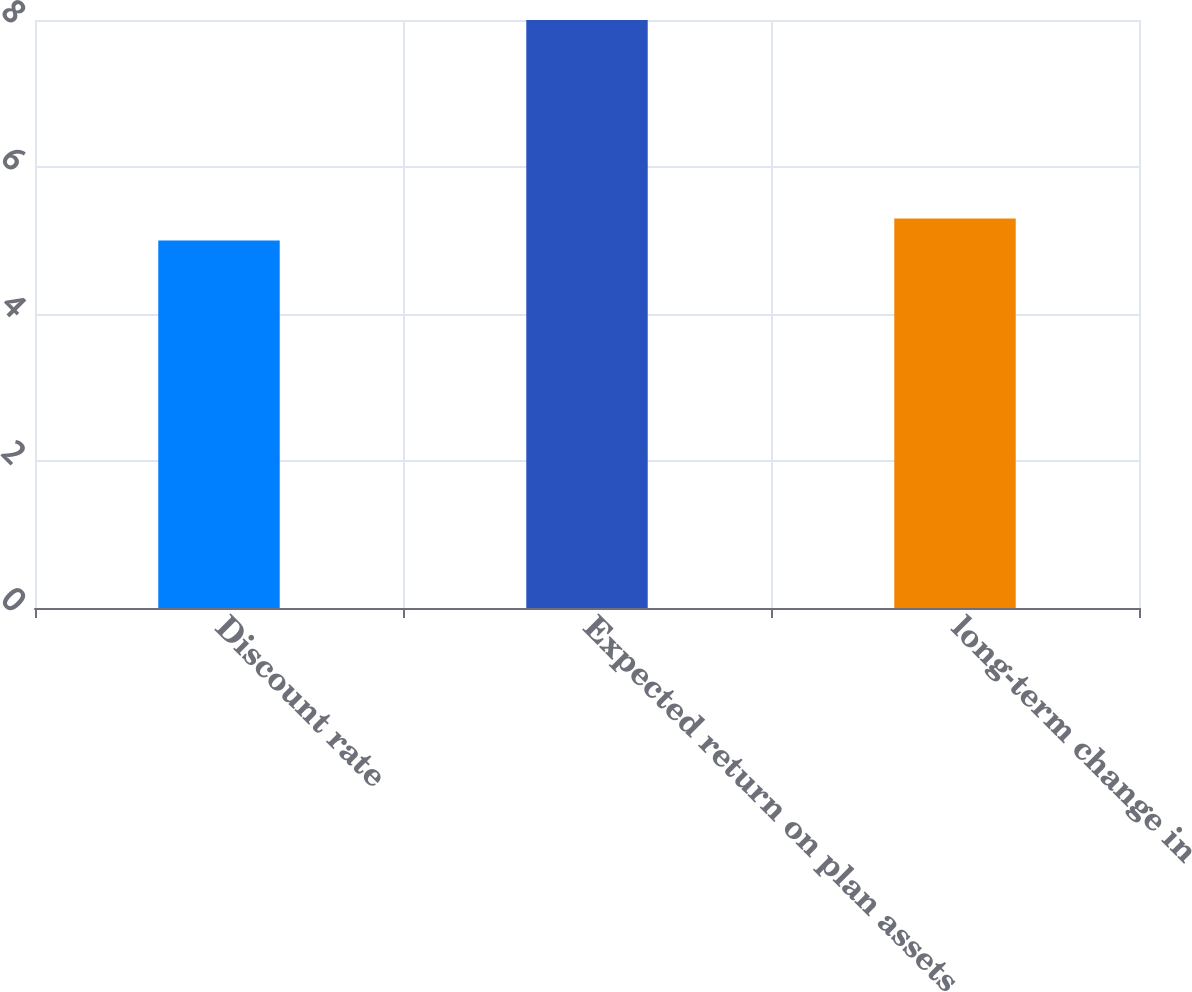Convert chart to OTSL. <chart><loc_0><loc_0><loc_500><loc_500><bar_chart><fcel>Discount rate<fcel>Expected return on plan assets<fcel>long-term change in<nl><fcel>5<fcel>8<fcel>5.3<nl></chart> 